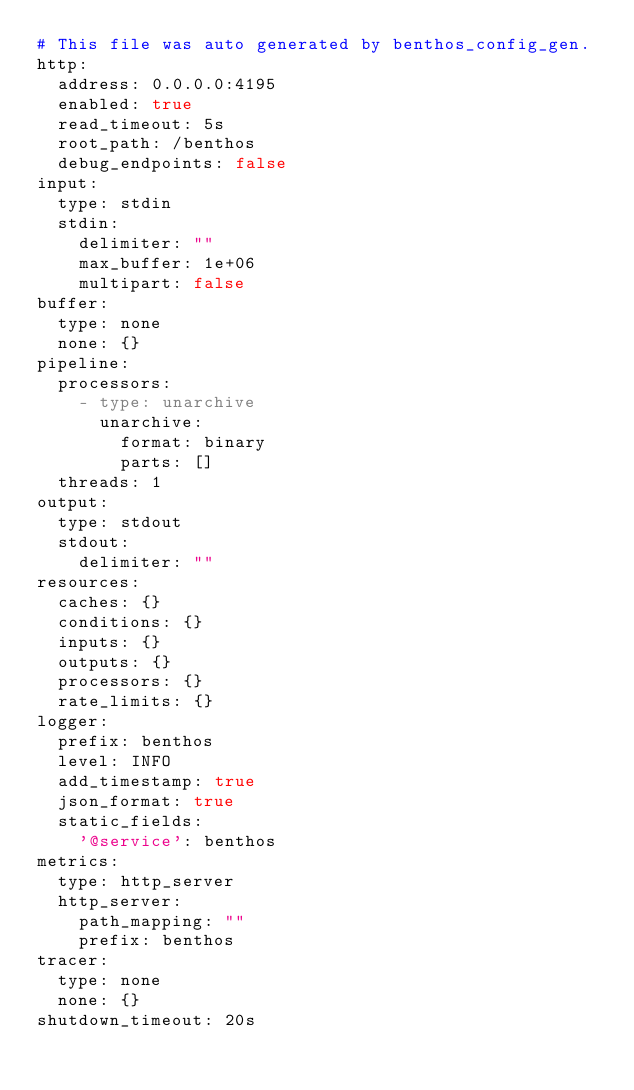<code> <loc_0><loc_0><loc_500><loc_500><_YAML_># This file was auto generated by benthos_config_gen.
http:
  address: 0.0.0.0:4195
  enabled: true
  read_timeout: 5s
  root_path: /benthos
  debug_endpoints: false
input:
  type: stdin
  stdin:
    delimiter: ""
    max_buffer: 1e+06
    multipart: false
buffer:
  type: none
  none: {}
pipeline:
  processors:
    - type: unarchive
      unarchive:
        format: binary
        parts: []
  threads: 1
output:
  type: stdout
  stdout:
    delimiter: ""
resources:
  caches: {}
  conditions: {}
  inputs: {}
  outputs: {}
  processors: {}
  rate_limits: {}
logger:
  prefix: benthos
  level: INFO
  add_timestamp: true
  json_format: true
  static_fields:
    '@service': benthos
metrics:
  type: http_server
  http_server:
    path_mapping: ""
    prefix: benthos
tracer:
  type: none
  none: {}
shutdown_timeout: 20s
</code> 